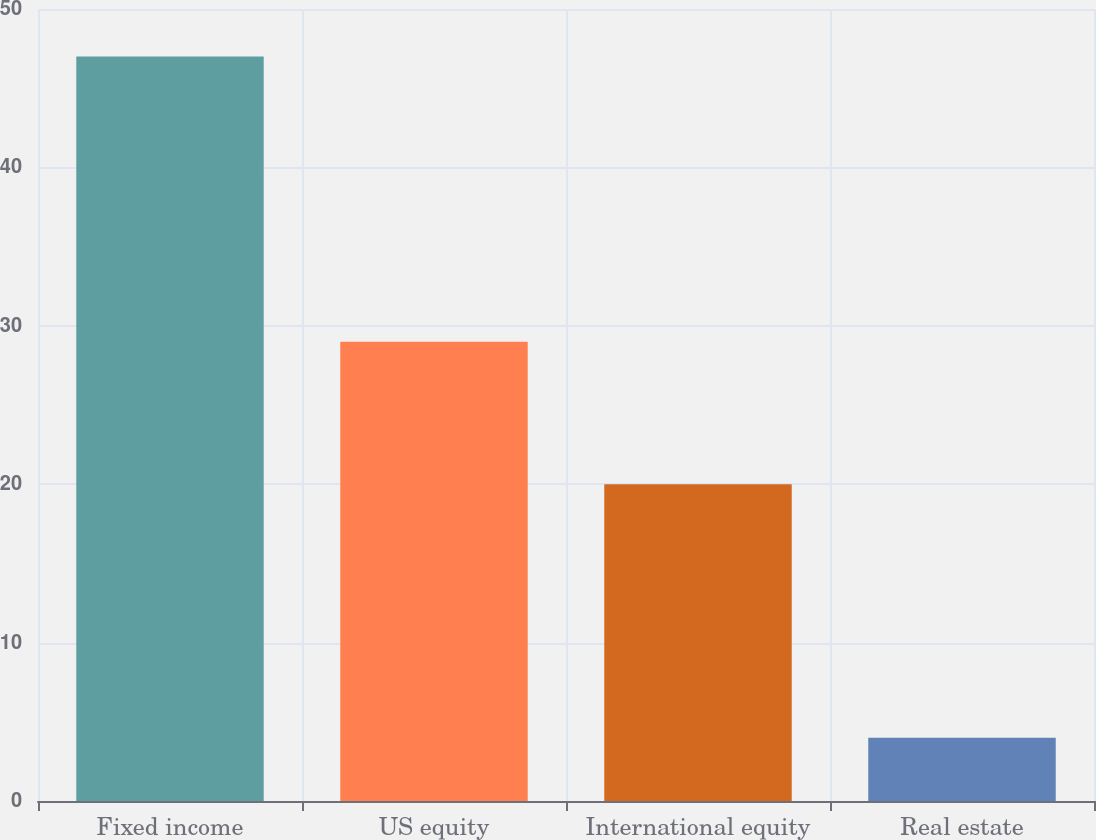<chart> <loc_0><loc_0><loc_500><loc_500><bar_chart><fcel>Fixed income<fcel>US equity<fcel>International equity<fcel>Real estate<nl><fcel>47<fcel>29<fcel>20<fcel>4<nl></chart> 